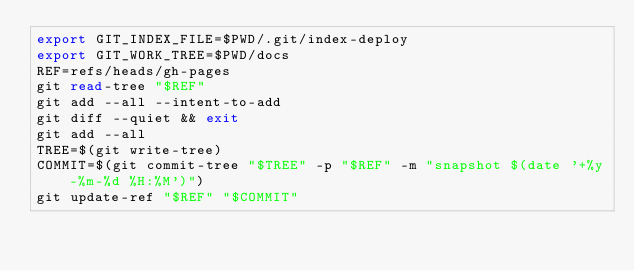Convert code to text. <code><loc_0><loc_0><loc_500><loc_500><_Bash_>export GIT_INDEX_FILE=$PWD/.git/index-deploy
export GIT_WORK_TREE=$PWD/docs
REF=refs/heads/gh-pages
git read-tree "$REF"
git add --all --intent-to-add
git diff --quiet && exit
git add --all
TREE=$(git write-tree)
COMMIT=$(git commit-tree "$TREE" -p "$REF" -m "snapshot $(date '+%y-%m-%d %H:%M')")
git update-ref "$REF" "$COMMIT"
</code> 